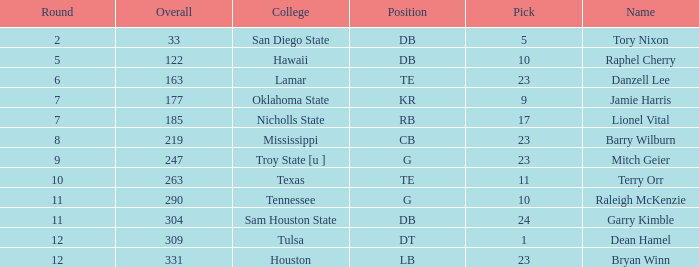Which Round is the highest one that has a Pick smaller than 10, and a Name of tory nixon? 2.0. 